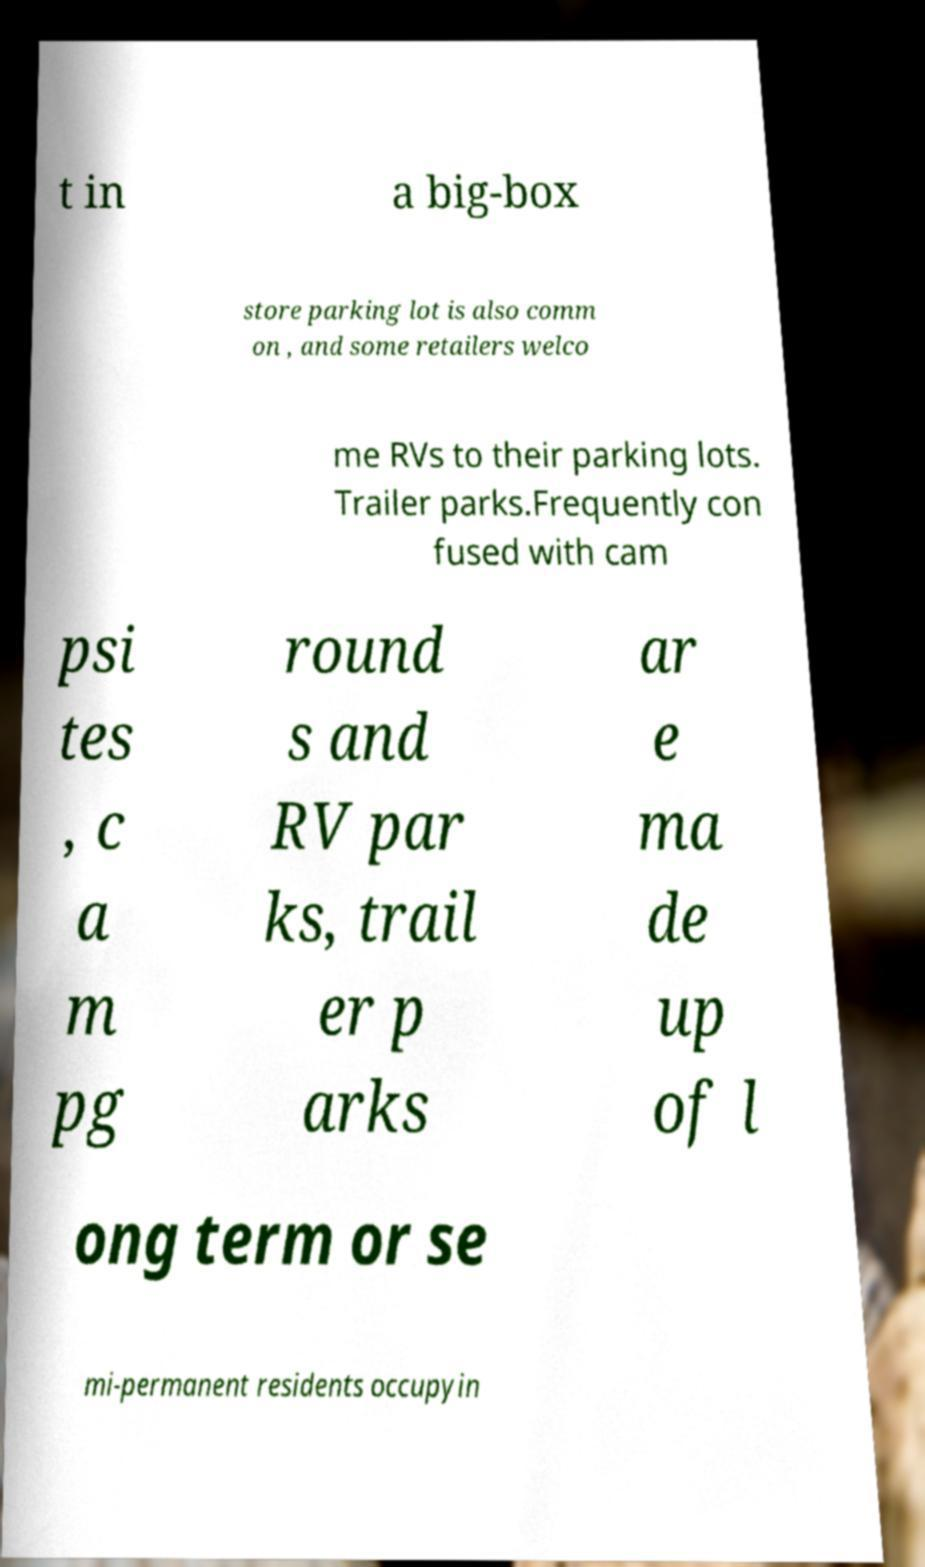There's text embedded in this image that I need extracted. Can you transcribe it verbatim? t in a big-box store parking lot is also comm on , and some retailers welco me RVs to their parking lots. Trailer parks.Frequently con fused with cam psi tes , c a m pg round s and RV par ks, trail er p arks ar e ma de up of l ong term or se mi-permanent residents occupyin 